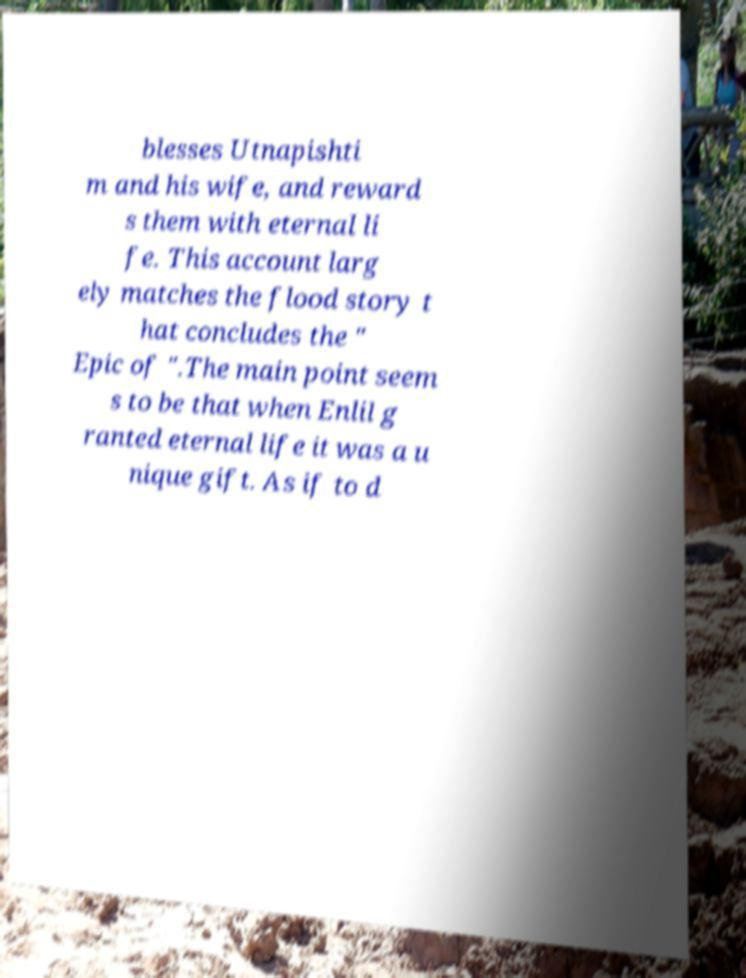Can you read and provide the text displayed in the image?This photo seems to have some interesting text. Can you extract and type it out for me? blesses Utnapishti m and his wife, and reward s them with eternal li fe. This account larg ely matches the flood story t hat concludes the " Epic of ".The main point seem s to be that when Enlil g ranted eternal life it was a u nique gift. As if to d 